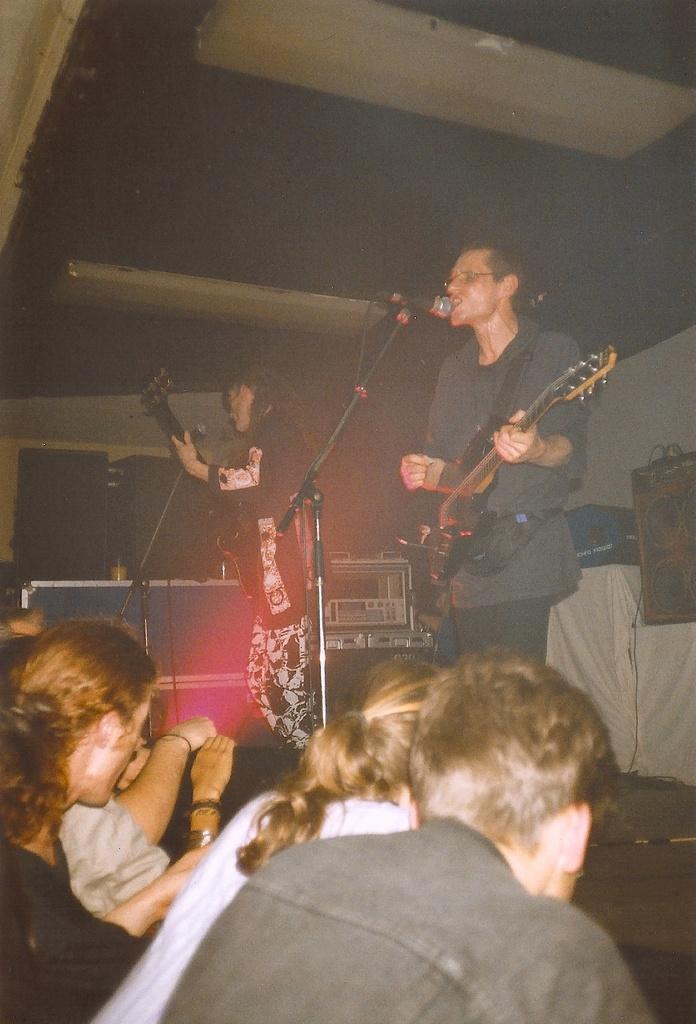Describe this image in one or two sentences. Here in the middle we can see a person playing guitar and singing a song with the microphone present in front of him and beside him we can see another person playing guitar having microphone in front of him and in front of them we can see people present and there are other musical instruments present behind them 